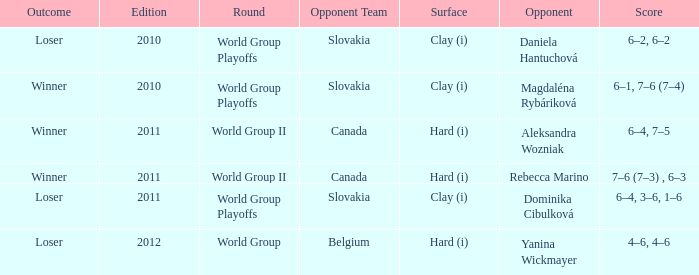What was the outcome of the game when the opponent was Magdaléna Rybáriková? Winner. 